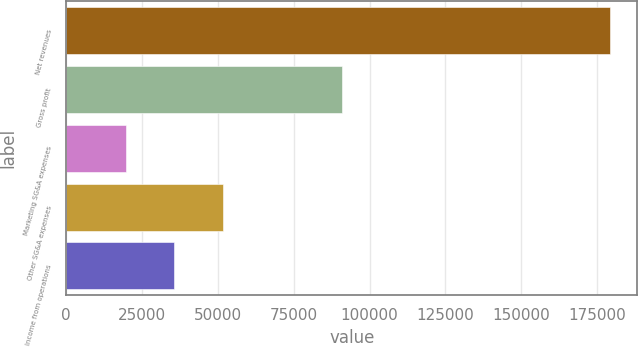<chart> <loc_0><loc_0><loc_500><loc_500><bar_chart><fcel>Net revenues<fcel>Gross profit<fcel>Marketing SG&A expenses<fcel>Other SG&A expenses<fcel>Income from operations<nl><fcel>179279<fcel>90942<fcel>19678<fcel>51598.2<fcel>35638.1<nl></chart> 